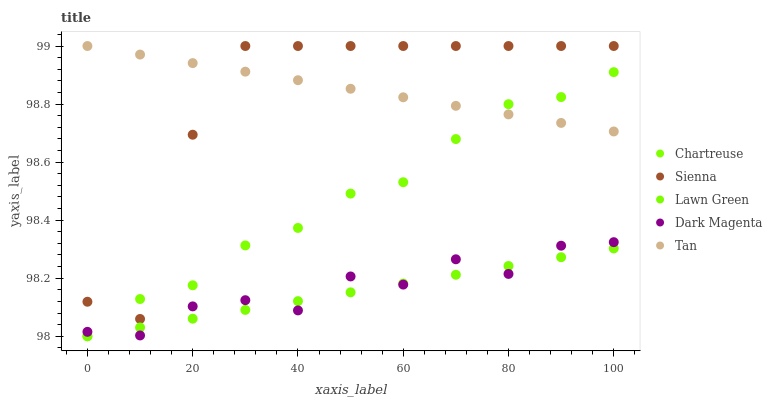Does Lawn Green have the minimum area under the curve?
Answer yes or no. Yes. Does Tan have the maximum area under the curve?
Answer yes or no. Yes. Does Chartreuse have the minimum area under the curve?
Answer yes or no. No. Does Chartreuse have the maximum area under the curve?
Answer yes or no. No. Is Tan the smoothest?
Answer yes or no. Yes. Is Sienna the roughest?
Answer yes or no. Yes. Is Lawn Green the smoothest?
Answer yes or no. No. Is Lawn Green the roughest?
Answer yes or no. No. Does Lawn Green have the lowest value?
Answer yes or no. Yes. Does Tan have the lowest value?
Answer yes or no. No. Does Tan have the highest value?
Answer yes or no. Yes. Does Chartreuse have the highest value?
Answer yes or no. No. Is Dark Magenta less than Tan?
Answer yes or no. Yes. Is Sienna greater than Lawn Green?
Answer yes or no. Yes. Does Tan intersect Chartreuse?
Answer yes or no. Yes. Is Tan less than Chartreuse?
Answer yes or no. No. Is Tan greater than Chartreuse?
Answer yes or no. No. Does Dark Magenta intersect Tan?
Answer yes or no. No. 